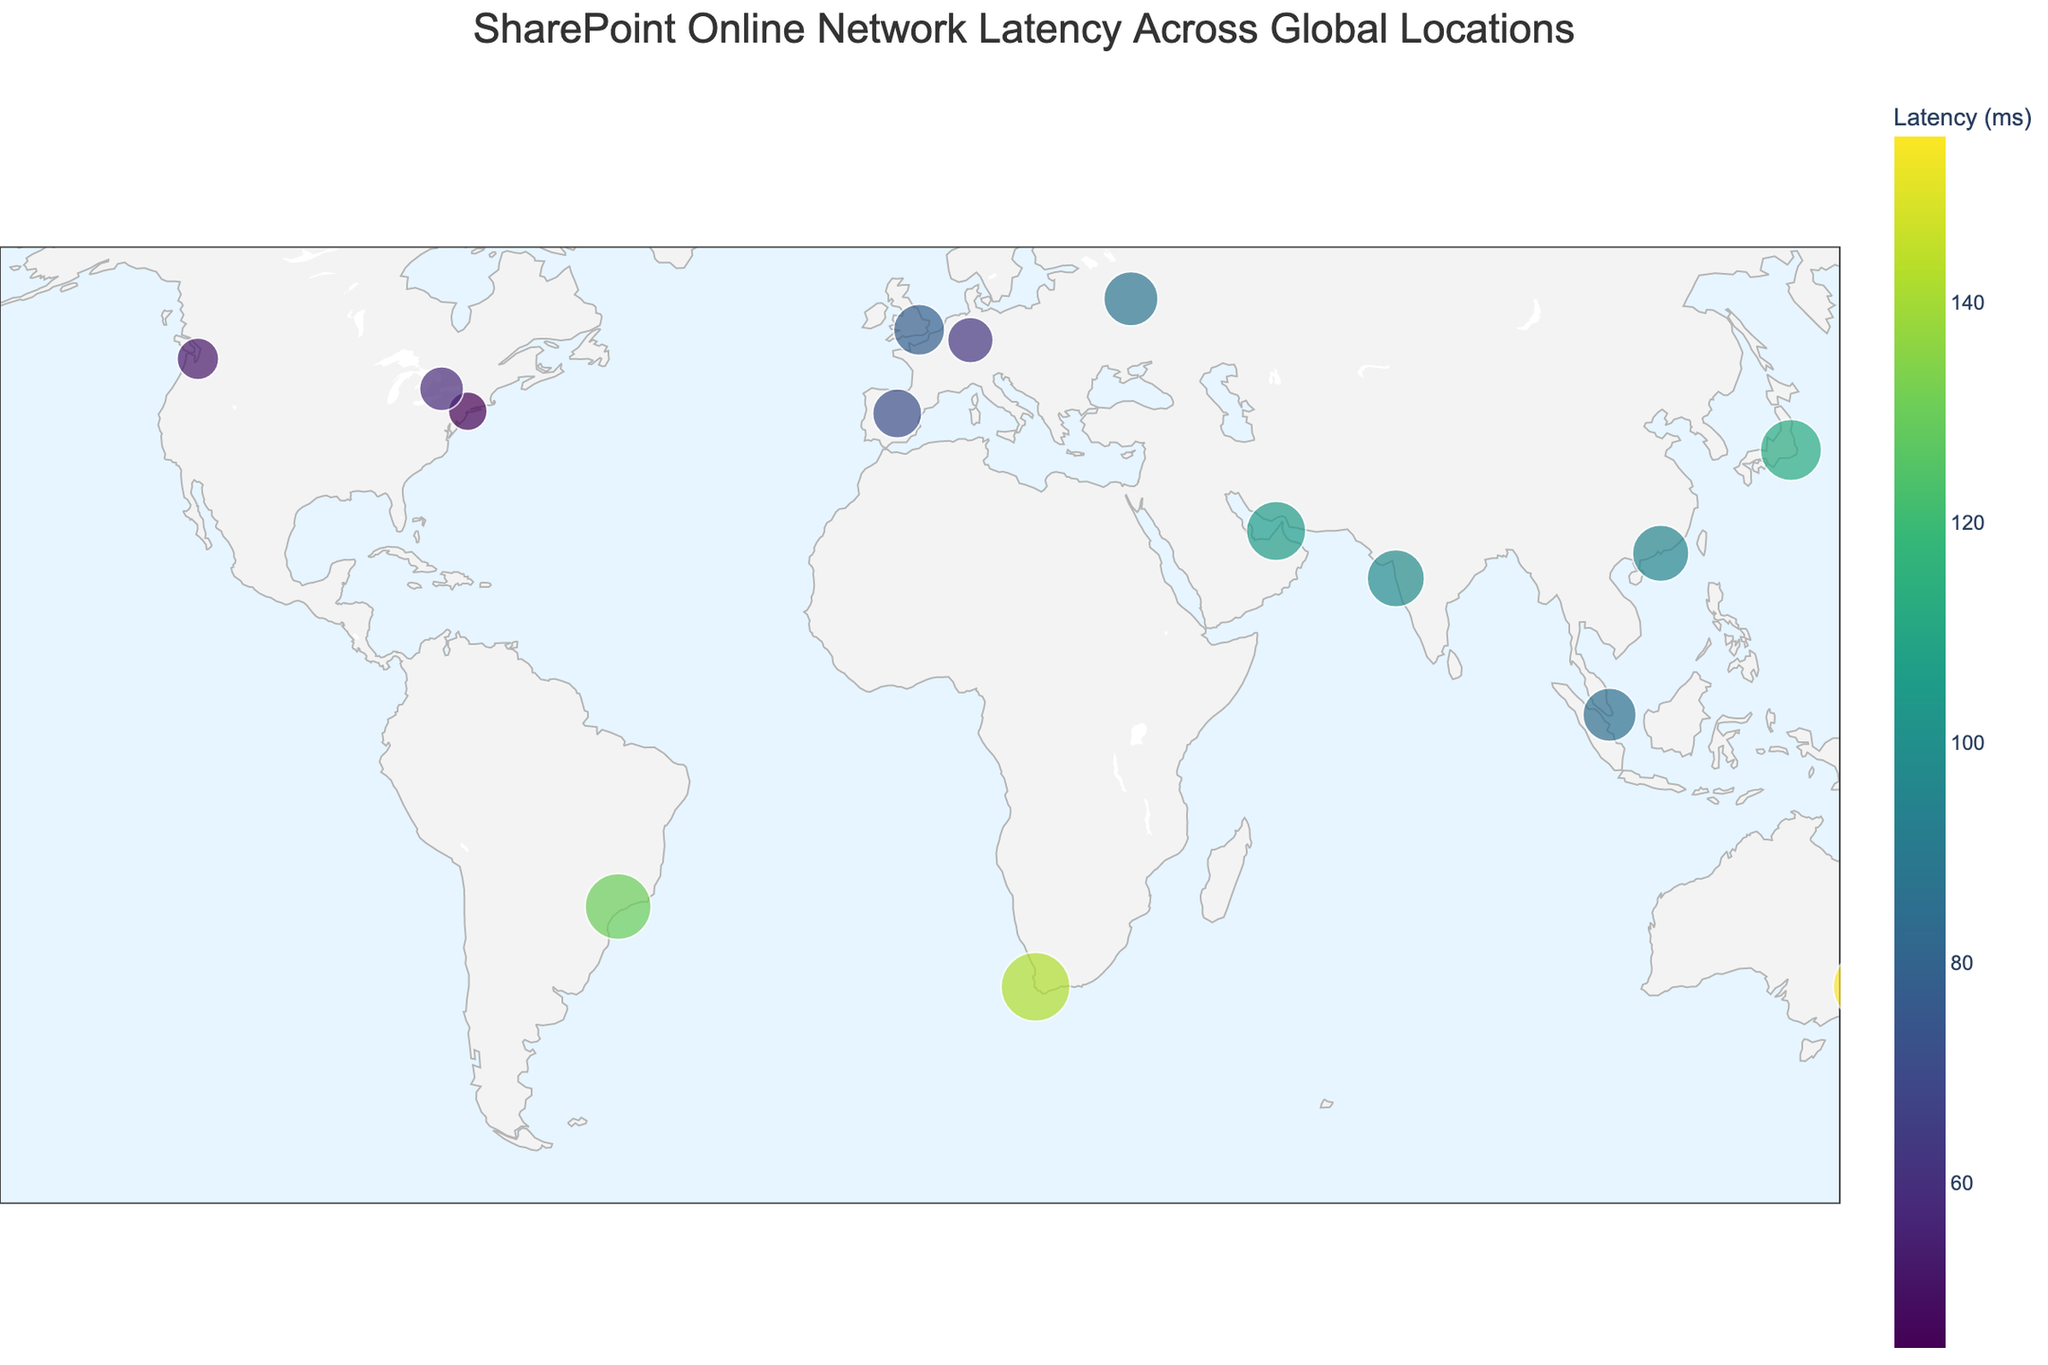What is the latency measurement for Mumbai? To find the latency measurement for Mumbai, locate the dot labeled "Mumbai" on the map, check the color and size, and verify the associated latency value.
Answer: 98 ms Which city has the highest network latency for accessing SharePoint Online? To determine which city has the highest latency, look for the largest and darkest-colored marker on the map. This represents the city with the highest latency value.
Answer: Sydney Compare the latency measurements between New York and London. Which city has a lower latency? Identify the data points for both New York and London by finding their positions and labels on the map. Then compare their associated latency values. New York has 45 ms and London has 78 ms, so New York has a lower latency.
Answer: New York What is the average latency for the cities in Europe? Identify European cities on the map (London, Frankfurt, Madrid, Moscow). Sum their latency values: 78 + 62 + 72 + 88 = 300. Then divide by the number of cities (4).
Answer: 75 ms Which location in Asia has the lowest latency for accessing SharePoint Online? Focus on Asian cities (Tokyo, Mumbai, Singapore, Hong Kong). Compare their latency values: Tokyo (112 ms), Mumbai (98 ms), Singapore (85 ms), and Hong Kong (95 ms). The lowest latency is for Singapore.
Answer: Singapore How does the latency in Cape Town compare to that in Sao Paulo? Locate both cities on the map and identify their latency values. Cape Town has a latency of 142 ms, whereas Sao Paulo has 130 ms. By comparing these, Cape Town has a higher latency.
Answer: Cape Town Which locations have a latency measurement greater than 100 ms? Check all points on the map and note those with latency values over 100 ms. These locations are Tokyo, Sydney, Sao Paulo, Dubai, and Cape Town.
Answer: Tokyo, Sydney, Sao Paulo, Dubai, Cape Town What is the difference in latency between the locations with the highest and lowest latency? Identify the locations with the highest (Sydney 155 ms) and lowest (New York 45 ms) latencies. Calculate the difference: 155 - 45 = 110 ms.
Answer: 110 ms How many locations have a latency measurement between 50 ms and 100 ms? Review each data point on the map to see if its latency falls within the 50-100 ms range. Count these locations: New York, London, Frankfurt, Singapore, Mumbai, Toronto, Hong Kong, Moscow, Madrid.
Answer: 9 locations 